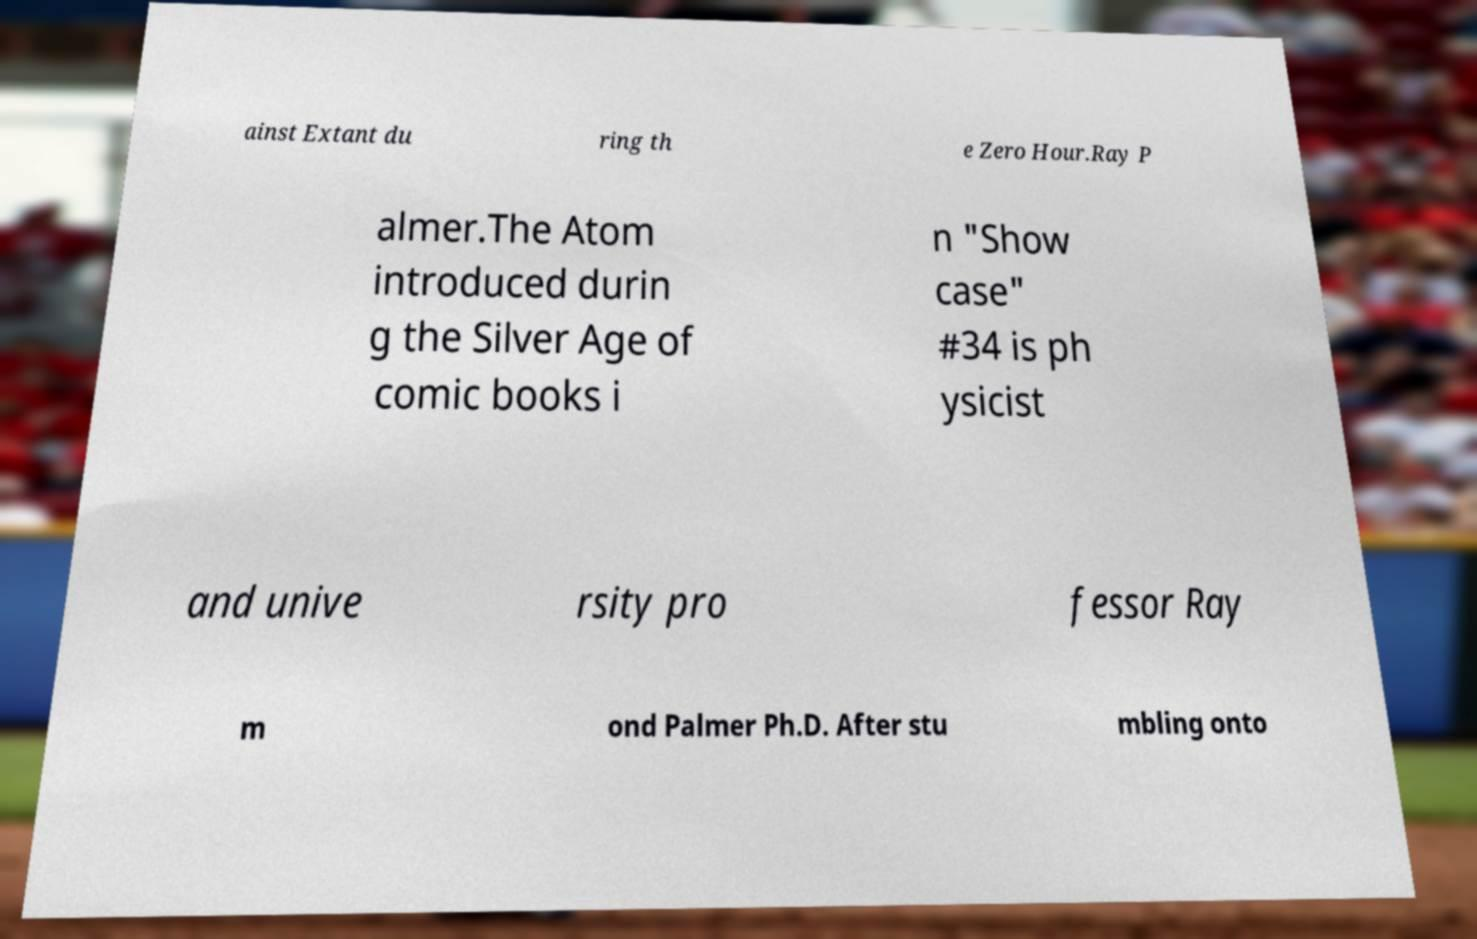Please read and relay the text visible in this image. What does it say? ainst Extant du ring th e Zero Hour.Ray P almer.The Atom introduced durin g the Silver Age of comic books i n "Show case" #34 is ph ysicist and unive rsity pro fessor Ray m ond Palmer Ph.D. After stu mbling onto 